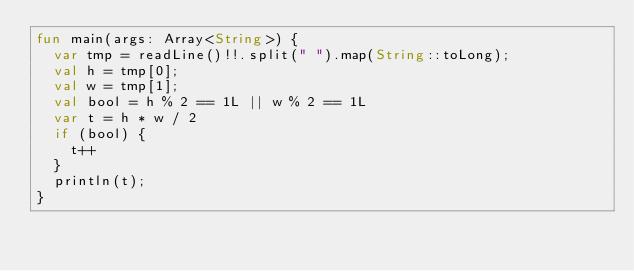<code> <loc_0><loc_0><loc_500><loc_500><_Kotlin_>fun main(args: Array<String>) {
  var tmp = readLine()!!.split(" ").map(String::toLong);
  val h = tmp[0];
  val w = tmp[1];
  val bool = h % 2 == 1L || w % 2 == 1L
  var t = h * w / 2
  if (bool) {
    t++
  }
  println(t);
}
</code> 